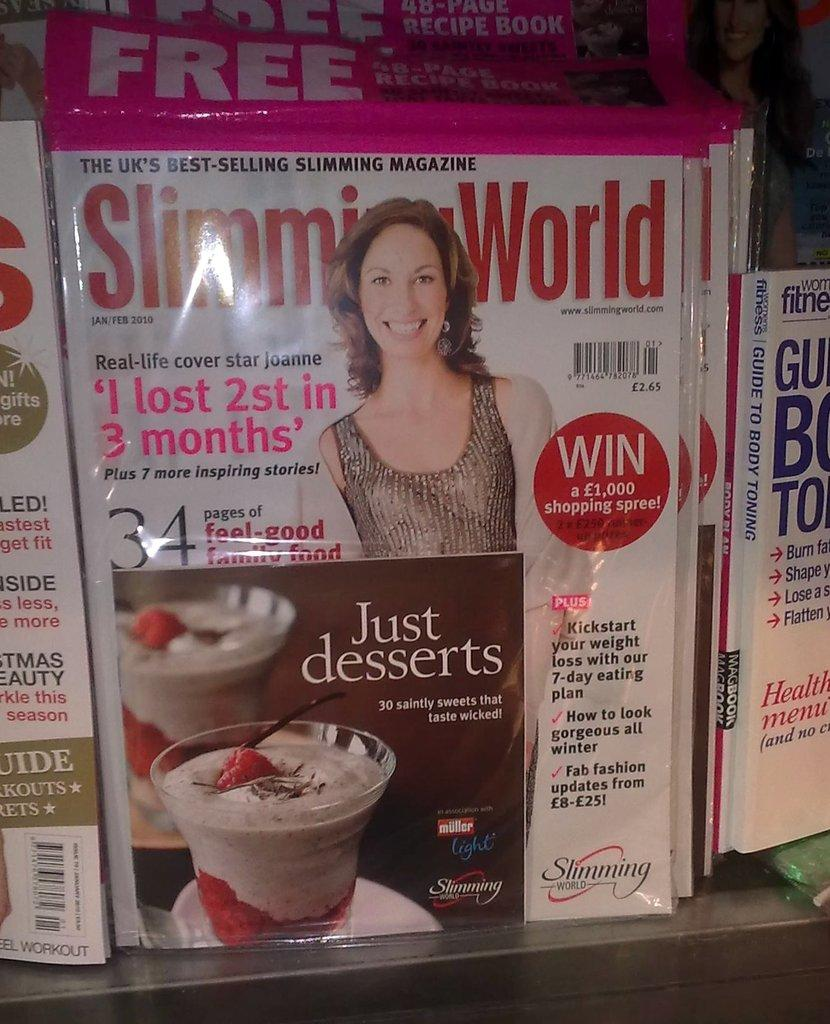<image>
Describe the image concisely. An insert for Just Desserts in inside the plastic wrap of Slimming World magazine. 